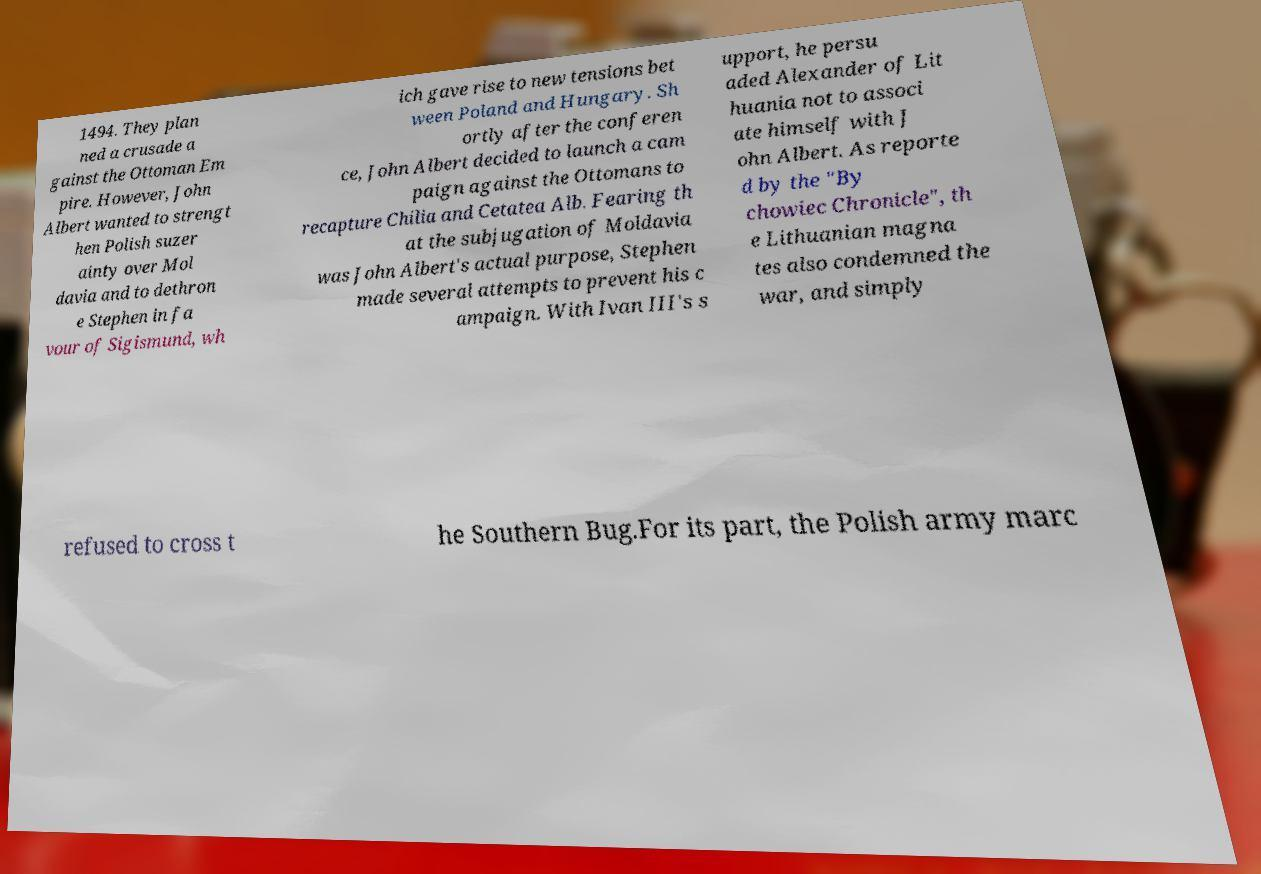For documentation purposes, I need the text within this image transcribed. Could you provide that? 1494. They plan ned a crusade a gainst the Ottoman Em pire. However, John Albert wanted to strengt hen Polish suzer ainty over Mol davia and to dethron e Stephen in fa vour of Sigismund, wh ich gave rise to new tensions bet ween Poland and Hungary. Sh ortly after the conferen ce, John Albert decided to launch a cam paign against the Ottomans to recapture Chilia and Cetatea Alb. Fearing th at the subjugation of Moldavia was John Albert's actual purpose, Stephen made several attempts to prevent his c ampaign. With Ivan III's s upport, he persu aded Alexander of Lit huania not to associ ate himself with J ohn Albert. As reporte d by the "By chowiec Chronicle", th e Lithuanian magna tes also condemned the war, and simply refused to cross t he Southern Bug.For its part, the Polish army marc 